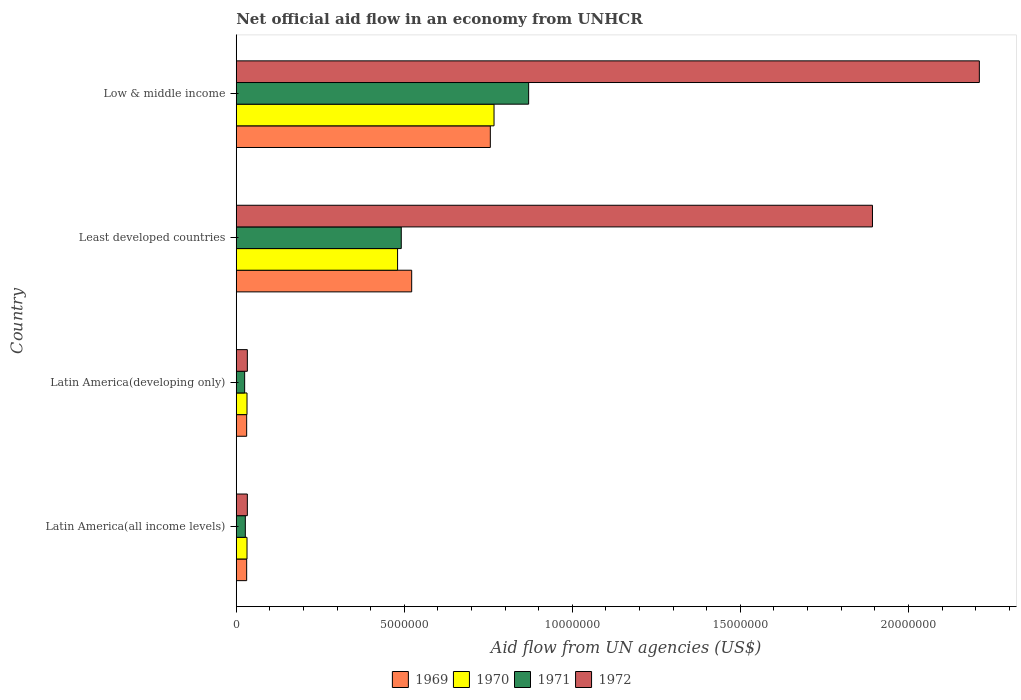How many different coloured bars are there?
Give a very brief answer. 4. Are the number of bars on each tick of the Y-axis equal?
Offer a terse response. Yes. How many bars are there on the 1st tick from the bottom?
Your answer should be very brief. 4. What is the label of the 2nd group of bars from the top?
Your response must be concise. Least developed countries. In how many cases, is the number of bars for a given country not equal to the number of legend labels?
Offer a very short reply. 0. What is the net official aid flow in 1971 in Least developed countries?
Ensure brevity in your answer.  4.91e+06. Across all countries, what is the maximum net official aid flow in 1972?
Your answer should be compact. 2.21e+07. Across all countries, what is the minimum net official aid flow in 1971?
Your answer should be very brief. 2.50e+05. In which country was the net official aid flow in 1970 maximum?
Offer a terse response. Low & middle income. In which country was the net official aid flow in 1971 minimum?
Ensure brevity in your answer.  Latin America(developing only). What is the total net official aid flow in 1971 in the graph?
Your response must be concise. 1.41e+07. What is the difference between the net official aid flow in 1969 in Latin America(developing only) and that in Low & middle income?
Offer a very short reply. -7.25e+06. What is the difference between the net official aid flow in 1972 in Least developed countries and the net official aid flow in 1970 in Low & middle income?
Offer a very short reply. 1.13e+07. What is the average net official aid flow in 1969 per country?
Provide a succinct answer. 3.35e+06. What is the difference between the net official aid flow in 1972 and net official aid flow in 1970 in Least developed countries?
Provide a succinct answer. 1.41e+07. What is the ratio of the net official aid flow in 1972 in Latin America(developing only) to that in Least developed countries?
Your answer should be very brief. 0.02. Is the net official aid flow in 1971 in Latin America(all income levels) less than that in Low & middle income?
Provide a succinct answer. Yes. What is the difference between the highest and the second highest net official aid flow in 1972?
Your answer should be very brief. 3.18e+06. What is the difference between the highest and the lowest net official aid flow in 1969?
Provide a succinct answer. 7.25e+06. In how many countries, is the net official aid flow in 1972 greater than the average net official aid flow in 1972 taken over all countries?
Ensure brevity in your answer.  2. Is it the case that in every country, the sum of the net official aid flow in 1969 and net official aid flow in 1971 is greater than the sum of net official aid flow in 1970 and net official aid flow in 1972?
Make the answer very short. No. What does the 2nd bar from the bottom in Least developed countries represents?
Your response must be concise. 1970. Is it the case that in every country, the sum of the net official aid flow in 1969 and net official aid flow in 1971 is greater than the net official aid flow in 1972?
Ensure brevity in your answer.  No. Does the graph contain any zero values?
Provide a short and direct response. No. How many legend labels are there?
Make the answer very short. 4. How are the legend labels stacked?
Offer a terse response. Horizontal. What is the title of the graph?
Keep it short and to the point. Net official aid flow in an economy from UNHCR. What is the label or title of the X-axis?
Offer a very short reply. Aid flow from UN agencies (US$). What is the label or title of the Y-axis?
Keep it short and to the point. Country. What is the Aid flow from UN agencies (US$) in 1969 in Latin America(all income levels)?
Offer a very short reply. 3.10e+05. What is the Aid flow from UN agencies (US$) in 1971 in Latin America(all income levels)?
Give a very brief answer. 2.70e+05. What is the Aid flow from UN agencies (US$) of 1969 in Latin America(developing only)?
Your response must be concise. 3.10e+05. What is the Aid flow from UN agencies (US$) in 1972 in Latin America(developing only)?
Make the answer very short. 3.30e+05. What is the Aid flow from UN agencies (US$) in 1969 in Least developed countries?
Your answer should be very brief. 5.22e+06. What is the Aid flow from UN agencies (US$) in 1970 in Least developed countries?
Offer a terse response. 4.80e+06. What is the Aid flow from UN agencies (US$) of 1971 in Least developed countries?
Your answer should be very brief. 4.91e+06. What is the Aid flow from UN agencies (US$) of 1972 in Least developed countries?
Your answer should be compact. 1.89e+07. What is the Aid flow from UN agencies (US$) in 1969 in Low & middle income?
Make the answer very short. 7.56e+06. What is the Aid flow from UN agencies (US$) in 1970 in Low & middle income?
Offer a terse response. 7.67e+06. What is the Aid flow from UN agencies (US$) in 1971 in Low & middle income?
Your answer should be compact. 8.70e+06. What is the Aid flow from UN agencies (US$) in 1972 in Low & middle income?
Keep it short and to the point. 2.21e+07. Across all countries, what is the maximum Aid flow from UN agencies (US$) in 1969?
Make the answer very short. 7.56e+06. Across all countries, what is the maximum Aid flow from UN agencies (US$) in 1970?
Make the answer very short. 7.67e+06. Across all countries, what is the maximum Aid flow from UN agencies (US$) of 1971?
Ensure brevity in your answer.  8.70e+06. Across all countries, what is the maximum Aid flow from UN agencies (US$) of 1972?
Make the answer very short. 2.21e+07. Across all countries, what is the minimum Aid flow from UN agencies (US$) in 1971?
Offer a very short reply. 2.50e+05. Across all countries, what is the minimum Aid flow from UN agencies (US$) of 1972?
Keep it short and to the point. 3.30e+05. What is the total Aid flow from UN agencies (US$) of 1969 in the graph?
Your response must be concise. 1.34e+07. What is the total Aid flow from UN agencies (US$) in 1970 in the graph?
Offer a very short reply. 1.31e+07. What is the total Aid flow from UN agencies (US$) of 1971 in the graph?
Provide a short and direct response. 1.41e+07. What is the total Aid flow from UN agencies (US$) of 1972 in the graph?
Offer a terse response. 4.17e+07. What is the difference between the Aid flow from UN agencies (US$) of 1969 in Latin America(all income levels) and that in Latin America(developing only)?
Keep it short and to the point. 0. What is the difference between the Aid flow from UN agencies (US$) of 1970 in Latin America(all income levels) and that in Latin America(developing only)?
Your answer should be very brief. 0. What is the difference between the Aid flow from UN agencies (US$) of 1972 in Latin America(all income levels) and that in Latin America(developing only)?
Your response must be concise. 0. What is the difference between the Aid flow from UN agencies (US$) of 1969 in Latin America(all income levels) and that in Least developed countries?
Offer a terse response. -4.91e+06. What is the difference between the Aid flow from UN agencies (US$) in 1970 in Latin America(all income levels) and that in Least developed countries?
Provide a short and direct response. -4.48e+06. What is the difference between the Aid flow from UN agencies (US$) of 1971 in Latin America(all income levels) and that in Least developed countries?
Your answer should be compact. -4.64e+06. What is the difference between the Aid flow from UN agencies (US$) of 1972 in Latin America(all income levels) and that in Least developed countries?
Keep it short and to the point. -1.86e+07. What is the difference between the Aid flow from UN agencies (US$) of 1969 in Latin America(all income levels) and that in Low & middle income?
Offer a very short reply. -7.25e+06. What is the difference between the Aid flow from UN agencies (US$) of 1970 in Latin America(all income levels) and that in Low & middle income?
Keep it short and to the point. -7.35e+06. What is the difference between the Aid flow from UN agencies (US$) in 1971 in Latin America(all income levels) and that in Low & middle income?
Your response must be concise. -8.43e+06. What is the difference between the Aid flow from UN agencies (US$) of 1972 in Latin America(all income levels) and that in Low & middle income?
Offer a terse response. -2.18e+07. What is the difference between the Aid flow from UN agencies (US$) of 1969 in Latin America(developing only) and that in Least developed countries?
Keep it short and to the point. -4.91e+06. What is the difference between the Aid flow from UN agencies (US$) of 1970 in Latin America(developing only) and that in Least developed countries?
Your answer should be very brief. -4.48e+06. What is the difference between the Aid flow from UN agencies (US$) of 1971 in Latin America(developing only) and that in Least developed countries?
Offer a very short reply. -4.66e+06. What is the difference between the Aid flow from UN agencies (US$) of 1972 in Latin America(developing only) and that in Least developed countries?
Offer a terse response. -1.86e+07. What is the difference between the Aid flow from UN agencies (US$) in 1969 in Latin America(developing only) and that in Low & middle income?
Your answer should be compact. -7.25e+06. What is the difference between the Aid flow from UN agencies (US$) in 1970 in Latin America(developing only) and that in Low & middle income?
Your answer should be compact. -7.35e+06. What is the difference between the Aid flow from UN agencies (US$) of 1971 in Latin America(developing only) and that in Low & middle income?
Your answer should be very brief. -8.45e+06. What is the difference between the Aid flow from UN agencies (US$) of 1972 in Latin America(developing only) and that in Low & middle income?
Offer a terse response. -2.18e+07. What is the difference between the Aid flow from UN agencies (US$) in 1969 in Least developed countries and that in Low & middle income?
Provide a short and direct response. -2.34e+06. What is the difference between the Aid flow from UN agencies (US$) of 1970 in Least developed countries and that in Low & middle income?
Make the answer very short. -2.87e+06. What is the difference between the Aid flow from UN agencies (US$) in 1971 in Least developed countries and that in Low & middle income?
Offer a terse response. -3.79e+06. What is the difference between the Aid flow from UN agencies (US$) in 1972 in Least developed countries and that in Low & middle income?
Give a very brief answer. -3.18e+06. What is the difference between the Aid flow from UN agencies (US$) of 1969 in Latin America(all income levels) and the Aid flow from UN agencies (US$) of 1970 in Least developed countries?
Provide a short and direct response. -4.49e+06. What is the difference between the Aid flow from UN agencies (US$) in 1969 in Latin America(all income levels) and the Aid flow from UN agencies (US$) in 1971 in Least developed countries?
Provide a short and direct response. -4.60e+06. What is the difference between the Aid flow from UN agencies (US$) in 1969 in Latin America(all income levels) and the Aid flow from UN agencies (US$) in 1972 in Least developed countries?
Provide a succinct answer. -1.86e+07. What is the difference between the Aid flow from UN agencies (US$) of 1970 in Latin America(all income levels) and the Aid flow from UN agencies (US$) of 1971 in Least developed countries?
Your answer should be compact. -4.59e+06. What is the difference between the Aid flow from UN agencies (US$) of 1970 in Latin America(all income levels) and the Aid flow from UN agencies (US$) of 1972 in Least developed countries?
Offer a terse response. -1.86e+07. What is the difference between the Aid flow from UN agencies (US$) in 1971 in Latin America(all income levels) and the Aid flow from UN agencies (US$) in 1972 in Least developed countries?
Your answer should be very brief. -1.87e+07. What is the difference between the Aid flow from UN agencies (US$) of 1969 in Latin America(all income levels) and the Aid flow from UN agencies (US$) of 1970 in Low & middle income?
Give a very brief answer. -7.36e+06. What is the difference between the Aid flow from UN agencies (US$) in 1969 in Latin America(all income levels) and the Aid flow from UN agencies (US$) in 1971 in Low & middle income?
Your answer should be compact. -8.39e+06. What is the difference between the Aid flow from UN agencies (US$) in 1969 in Latin America(all income levels) and the Aid flow from UN agencies (US$) in 1972 in Low & middle income?
Your response must be concise. -2.18e+07. What is the difference between the Aid flow from UN agencies (US$) in 1970 in Latin America(all income levels) and the Aid flow from UN agencies (US$) in 1971 in Low & middle income?
Offer a very short reply. -8.38e+06. What is the difference between the Aid flow from UN agencies (US$) in 1970 in Latin America(all income levels) and the Aid flow from UN agencies (US$) in 1972 in Low & middle income?
Keep it short and to the point. -2.18e+07. What is the difference between the Aid flow from UN agencies (US$) of 1971 in Latin America(all income levels) and the Aid flow from UN agencies (US$) of 1972 in Low & middle income?
Keep it short and to the point. -2.18e+07. What is the difference between the Aid flow from UN agencies (US$) in 1969 in Latin America(developing only) and the Aid flow from UN agencies (US$) in 1970 in Least developed countries?
Your answer should be compact. -4.49e+06. What is the difference between the Aid flow from UN agencies (US$) of 1969 in Latin America(developing only) and the Aid flow from UN agencies (US$) of 1971 in Least developed countries?
Provide a short and direct response. -4.60e+06. What is the difference between the Aid flow from UN agencies (US$) in 1969 in Latin America(developing only) and the Aid flow from UN agencies (US$) in 1972 in Least developed countries?
Offer a very short reply. -1.86e+07. What is the difference between the Aid flow from UN agencies (US$) in 1970 in Latin America(developing only) and the Aid flow from UN agencies (US$) in 1971 in Least developed countries?
Make the answer very short. -4.59e+06. What is the difference between the Aid flow from UN agencies (US$) of 1970 in Latin America(developing only) and the Aid flow from UN agencies (US$) of 1972 in Least developed countries?
Provide a short and direct response. -1.86e+07. What is the difference between the Aid flow from UN agencies (US$) of 1971 in Latin America(developing only) and the Aid flow from UN agencies (US$) of 1972 in Least developed countries?
Your response must be concise. -1.87e+07. What is the difference between the Aid flow from UN agencies (US$) in 1969 in Latin America(developing only) and the Aid flow from UN agencies (US$) in 1970 in Low & middle income?
Your answer should be compact. -7.36e+06. What is the difference between the Aid flow from UN agencies (US$) in 1969 in Latin America(developing only) and the Aid flow from UN agencies (US$) in 1971 in Low & middle income?
Give a very brief answer. -8.39e+06. What is the difference between the Aid flow from UN agencies (US$) of 1969 in Latin America(developing only) and the Aid flow from UN agencies (US$) of 1972 in Low & middle income?
Offer a very short reply. -2.18e+07. What is the difference between the Aid flow from UN agencies (US$) of 1970 in Latin America(developing only) and the Aid flow from UN agencies (US$) of 1971 in Low & middle income?
Ensure brevity in your answer.  -8.38e+06. What is the difference between the Aid flow from UN agencies (US$) of 1970 in Latin America(developing only) and the Aid flow from UN agencies (US$) of 1972 in Low & middle income?
Keep it short and to the point. -2.18e+07. What is the difference between the Aid flow from UN agencies (US$) in 1971 in Latin America(developing only) and the Aid flow from UN agencies (US$) in 1972 in Low & middle income?
Your answer should be compact. -2.19e+07. What is the difference between the Aid flow from UN agencies (US$) in 1969 in Least developed countries and the Aid flow from UN agencies (US$) in 1970 in Low & middle income?
Keep it short and to the point. -2.45e+06. What is the difference between the Aid flow from UN agencies (US$) in 1969 in Least developed countries and the Aid flow from UN agencies (US$) in 1971 in Low & middle income?
Provide a succinct answer. -3.48e+06. What is the difference between the Aid flow from UN agencies (US$) of 1969 in Least developed countries and the Aid flow from UN agencies (US$) of 1972 in Low & middle income?
Offer a very short reply. -1.69e+07. What is the difference between the Aid flow from UN agencies (US$) of 1970 in Least developed countries and the Aid flow from UN agencies (US$) of 1971 in Low & middle income?
Your answer should be very brief. -3.90e+06. What is the difference between the Aid flow from UN agencies (US$) in 1970 in Least developed countries and the Aid flow from UN agencies (US$) in 1972 in Low & middle income?
Offer a very short reply. -1.73e+07. What is the difference between the Aid flow from UN agencies (US$) of 1971 in Least developed countries and the Aid flow from UN agencies (US$) of 1972 in Low & middle income?
Provide a succinct answer. -1.72e+07. What is the average Aid flow from UN agencies (US$) of 1969 per country?
Offer a very short reply. 3.35e+06. What is the average Aid flow from UN agencies (US$) of 1970 per country?
Offer a very short reply. 3.28e+06. What is the average Aid flow from UN agencies (US$) of 1971 per country?
Keep it short and to the point. 3.53e+06. What is the average Aid flow from UN agencies (US$) of 1972 per country?
Provide a succinct answer. 1.04e+07. What is the difference between the Aid flow from UN agencies (US$) in 1969 and Aid flow from UN agencies (US$) in 1970 in Latin America(all income levels)?
Make the answer very short. -10000. What is the difference between the Aid flow from UN agencies (US$) in 1969 and Aid flow from UN agencies (US$) in 1972 in Latin America(all income levels)?
Provide a short and direct response. -2.00e+04. What is the difference between the Aid flow from UN agencies (US$) of 1971 and Aid flow from UN agencies (US$) of 1972 in Latin America(all income levels)?
Provide a succinct answer. -6.00e+04. What is the difference between the Aid flow from UN agencies (US$) in 1969 and Aid flow from UN agencies (US$) in 1971 in Latin America(developing only)?
Your answer should be very brief. 6.00e+04. What is the difference between the Aid flow from UN agencies (US$) of 1969 and Aid flow from UN agencies (US$) of 1972 in Latin America(developing only)?
Your answer should be compact. -2.00e+04. What is the difference between the Aid flow from UN agencies (US$) in 1970 and Aid flow from UN agencies (US$) in 1972 in Latin America(developing only)?
Offer a very short reply. -10000. What is the difference between the Aid flow from UN agencies (US$) of 1971 and Aid flow from UN agencies (US$) of 1972 in Latin America(developing only)?
Your answer should be very brief. -8.00e+04. What is the difference between the Aid flow from UN agencies (US$) in 1969 and Aid flow from UN agencies (US$) in 1970 in Least developed countries?
Give a very brief answer. 4.20e+05. What is the difference between the Aid flow from UN agencies (US$) in 1969 and Aid flow from UN agencies (US$) in 1972 in Least developed countries?
Provide a short and direct response. -1.37e+07. What is the difference between the Aid flow from UN agencies (US$) of 1970 and Aid flow from UN agencies (US$) of 1972 in Least developed countries?
Ensure brevity in your answer.  -1.41e+07. What is the difference between the Aid flow from UN agencies (US$) in 1971 and Aid flow from UN agencies (US$) in 1972 in Least developed countries?
Make the answer very short. -1.40e+07. What is the difference between the Aid flow from UN agencies (US$) in 1969 and Aid flow from UN agencies (US$) in 1970 in Low & middle income?
Give a very brief answer. -1.10e+05. What is the difference between the Aid flow from UN agencies (US$) in 1969 and Aid flow from UN agencies (US$) in 1971 in Low & middle income?
Your response must be concise. -1.14e+06. What is the difference between the Aid flow from UN agencies (US$) of 1969 and Aid flow from UN agencies (US$) of 1972 in Low & middle income?
Provide a short and direct response. -1.46e+07. What is the difference between the Aid flow from UN agencies (US$) of 1970 and Aid flow from UN agencies (US$) of 1971 in Low & middle income?
Give a very brief answer. -1.03e+06. What is the difference between the Aid flow from UN agencies (US$) in 1970 and Aid flow from UN agencies (US$) in 1972 in Low & middle income?
Keep it short and to the point. -1.44e+07. What is the difference between the Aid flow from UN agencies (US$) of 1971 and Aid flow from UN agencies (US$) of 1972 in Low & middle income?
Provide a short and direct response. -1.34e+07. What is the ratio of the Aid flow from UN agencies (US$) of 1969 in Latin America(all income levels) to that in Latin America(developing only)?
Make the answer very short. 1. What is the ratio of the Aid flow from UN agencies (US$) in 1971 in Latin America(all income levels) to that in Latin America(developing only)?
Provide a succinct answer. 1.08. What is the ratio of the Aid flow from UN agencies (US$) of 1969 in Latin America(all income levels) to that in Least developed countries?
Provide a short and direct response. 0.06. What is the ratio of the Aid flow from UN agencies (US$) in 1970 in Latin America(all income levels) to that in Least developed countries?
Provide a succinct answer. 0.07. What is the ratio of the Aid flow from UN agencies (US$) of 1971 in Latin America(all income levels) to that in Least developed countries?
Provide a succinct answer. 0.06. What is the ratio of the Aid flow from UN agencies (US$) of 1972 in Latin America(all income levels) to that in Least developed countries?
Your answer should be very brief. 0.02. What is the ratio of the Aid flow from UN agencies (US$) in 1969 in Latin America(all income levels) to that in Low & middle income?
Keep it short and to the point. 0.04. What is the ratio of the Aid flow from UN agencies (US$) of 1970 in Latin America(all income levels) to that in Low & middle income?
Your response must be concise. 0.04. What is the ratio of the Aid flow from UN agencies (US$) of 1971 in Latin America(all income levels) to that in Low & middle income?
Offer a terse response. 0.03. What is the ratio of the Aid flow from UN agencies (US$) of 1972 in Latin America(all income levels) to that in Low & middle income?
Your answer should be compact. 0.01. What is the ratio of the Aid flow from UN agencies (US$) of 1969 in Latin America(developing only) to that in Least developed countries?
Your response must be concise. 0.06. What is the ratio of the Aid flow from UN agencies (US$) in 1970 in Latin America(developing only) to that in Least developed countries?
Your answer should be compact. 0.07. What is the ratio of the Aid flow from UN agencies (US$) in 1971 in Latin America(developing only) to that in Least developed countries?
Give a very brief answer. 0.05. What is the ratio of the Aid flow from UN agencies (US$) of 1972 in Latin America(developing only) to that in Least developed countries?
Keep it short and to the point. 0.02. What is the ratio of the Aid flow from UN agencies (US$) in 1969 in Latin America(developing only) to that in Low & middle income?
Offer a terse response. 0.04. What is the ratio of the Aid flow from UN agencies (US$) in 1970 in Latin America(developing only) to that in Low & middle income?
Your answer should be compact. 0.04. What is the ratio of the Aid flow from UN agencies (US$) in 1971 in Latin America(developing only) to that in Low & middle income?
Offer a very short reply. 0.03. What is the ratio of the Aid flow from UN agencies (US$) in 1972 in Latin America(developing only) to that in Low & middle income?
Provide a succinct answer. 0.01. What is the ratio of the Aid flow from UN agencies (US$) of 1969 in Least developed countries to that in Low & middle income?
Offer a very short reply. 0.69. What is the ratio of the Aid flow from UN agencies (US$) of 1970 in Least developed countries to that in Low & middle income?
Your answer should be compact. 0.63. What is the ratio of the Aid flow from UN agencies (US$) in 1971 in Least developed countries to that in Low & middle income?
Keep it short and to the point. 0.56. What is the ratio of the Aid flow from UN agencies (US$) in 1972 in Least developed countries to that in Low & middle income?
Your response must be concise. 0.86. What is the difference between the highest and the second highest Aid flow from UN agencies (US$) of 1969?
Make the answer very short. 2.34e+06. What is the difference between the highest and the second highest Aid flow from UN agencies (US$) in 1970?
Offer a very short reply. 2.87e+06. What is the difference between the highest and the second highest Aid flow from UN agencies (US$) in 1971?
Keep it short and to the point. 3.79e+06. What is the difference between the highest and the second highest Aid flow from UN agencies (US$) of 1972?
Offer a very short reply. 3.18e+06. What is the difference between the highest and the lowest Aid flow from UN agencies (US$) in 1969?
Keep it short and to the point. 7.25e+06. What is the difference between the highest and the lowest Aid flow from UN agencies (US$) in 1970?
Your answer should be compact. 7.35e+06. What is the difference between the highest and the lowest Aid flow from UN agencies (US$) in 1971?
Give a very brief answer. 8.45e+06. What is the difference between the highest and the lowest Aid flow from UN agencies (US$) in 1972?
Your response must be concise. 2.18e+07. 